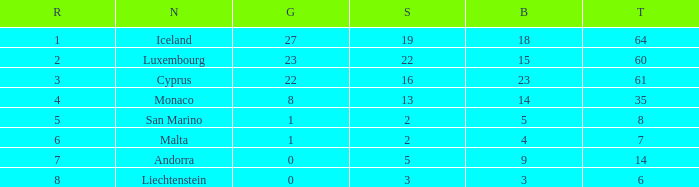How many bronzes for nations with over 22 golds and ranked under 2? 18.0. 